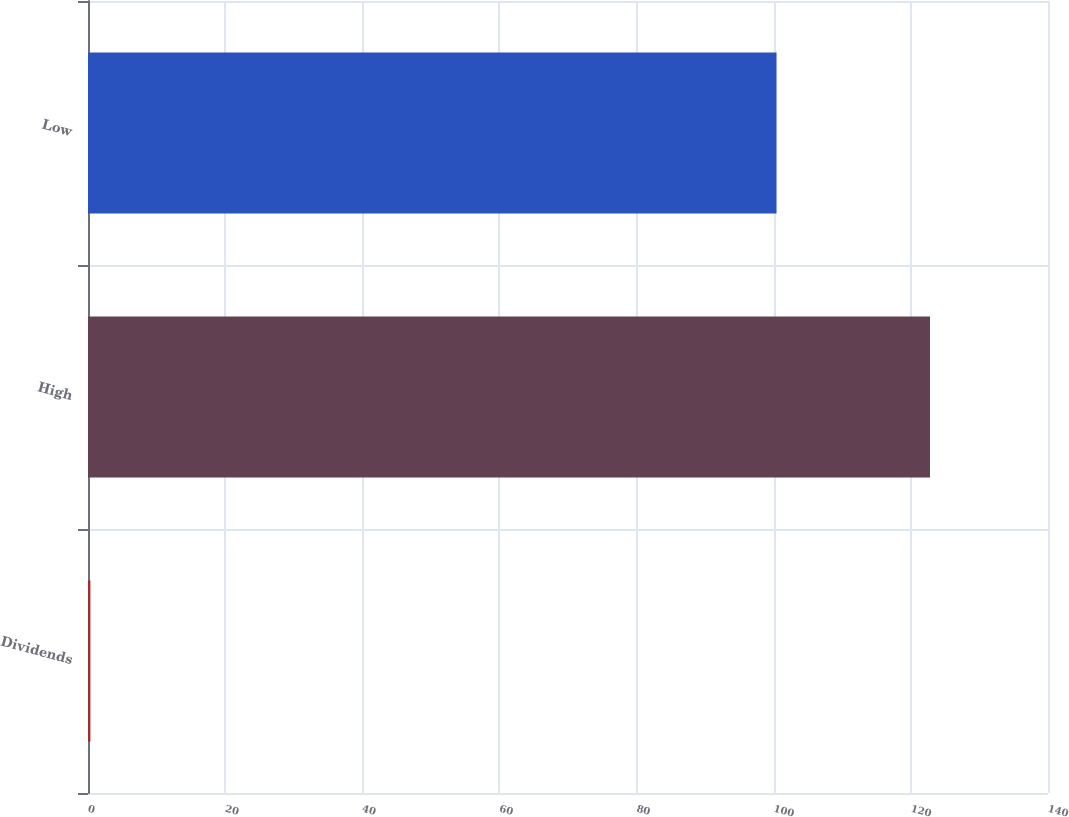Convert chart. <chart><loc_0><loc_0><loc_500><loc_500><bar_chart><fcel>Dividends<fcel>High<fcel>Low<nl><fcel>0.35<fcel>122.79<fcel>100.41<nl></chart> 